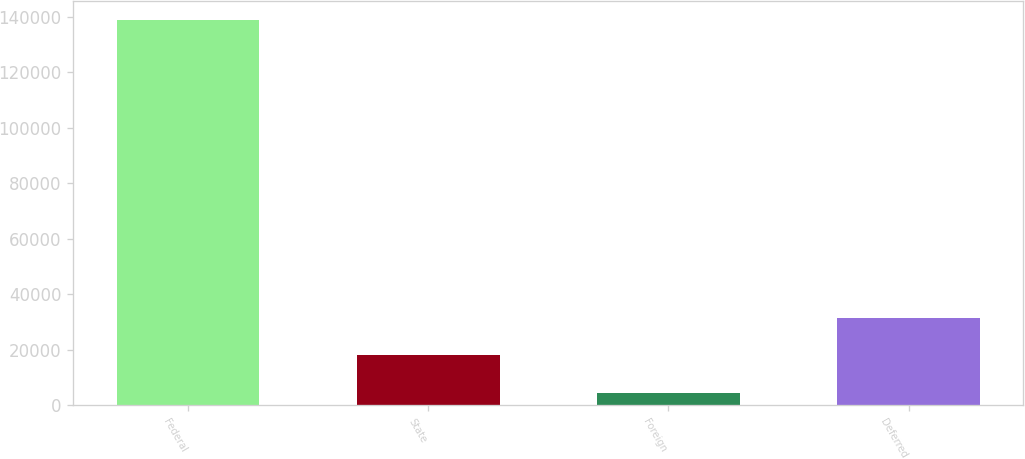Convert chart to OTSL. <chart><loc_0><loc_0><loc_500><loc_500><bar_chart><fcel>Federal<fcel>State<fcel>Foreign<fcel>Deferred<nl><fcel>138596<fcel>18011.3<fcel>4613<fcel>31409.6<nl></chart> 